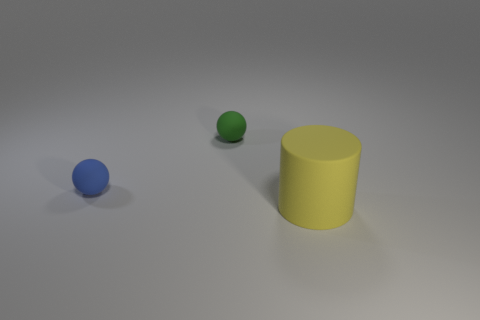Add 3 large metal things. How many objects exist? 6 Subtract all balls. How many objects are left? 1 Add 1 blue matte things. How many blue matte things exist? 2 Subtract 0 purple spheres. How many objects are left? 3 Subtract all big yellow matte cylinders. Subtract all green things. How many objects are left? 1 Add 3 balls. How many balls are left? 5 